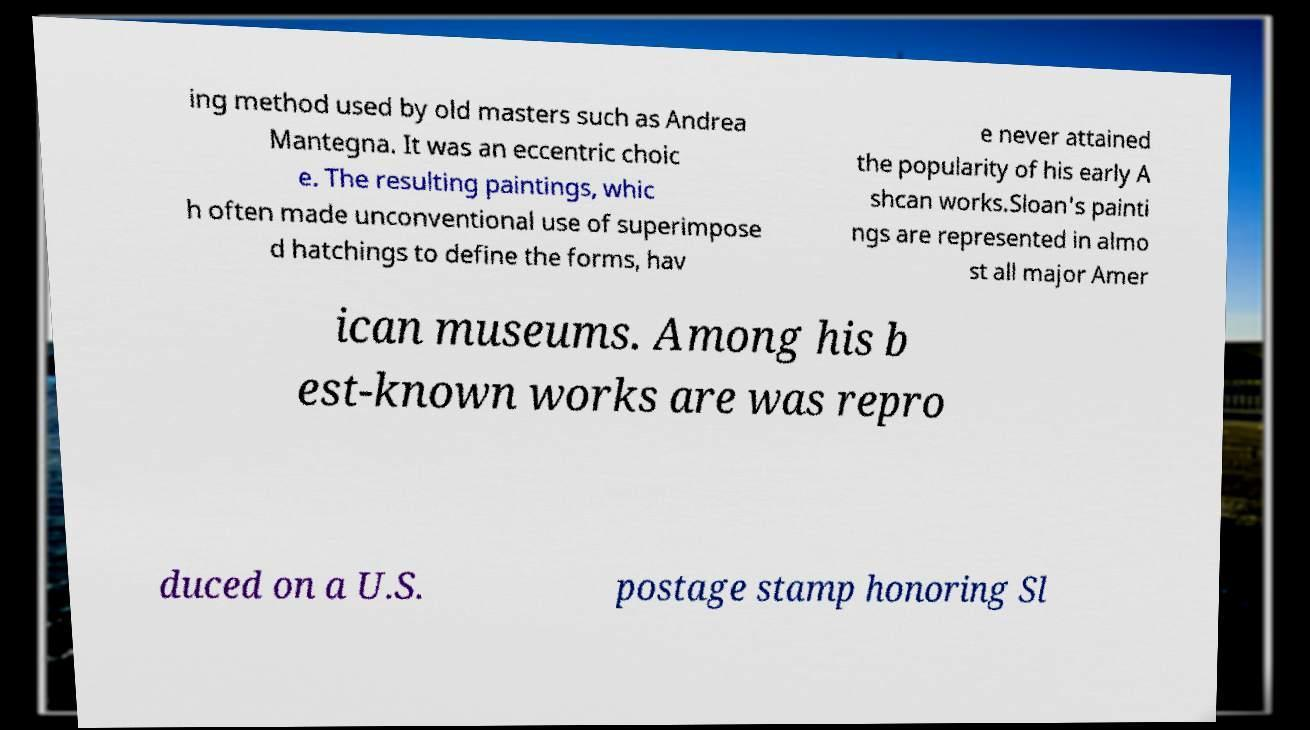Could you assist in decoding the text presented in this image and type it out clearly? ing method used by old masters such as Andrea Mantegna. It was an eccentric choic e. The resulting paintings, whic h often made unconventional use of superimpose d hatchings to define the forms, hav e never attained the popularity of his early A shcan works.Sloan's painti ngs are represented in almo st all major Amer ican museums. Among his b est-known works are was repro duced on a U.S. postage stamp honoring Sl 